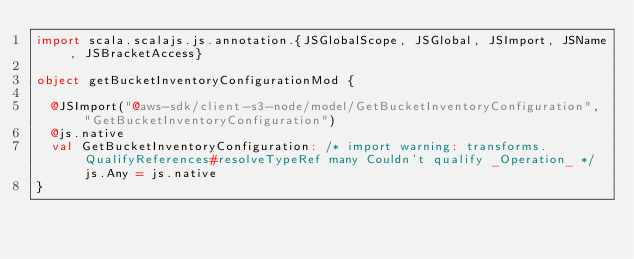Convert code to text. <code><loc_0><loc_0><loc_500><loc_500><_Scala_>import scala.scalajs.js.annotation.{JSGlobalScope, JSGlobal, JSImport, JSName, JSBracketAccess}

object getBucketInventoryConfigurationMod {
  
  @JSImport("@aws-sdk/client-s3-node/model/GetBucketInventoryConfiguration", "GetBucketInventoryConfiguration")
  @js.native
  val GetBucketInventoryConfiguration: /* import warning: transforms.QualifyReferences#resolveTypeRef many Couldn't qualify _Operation_ */ js.Any = js.native
}
</code> 